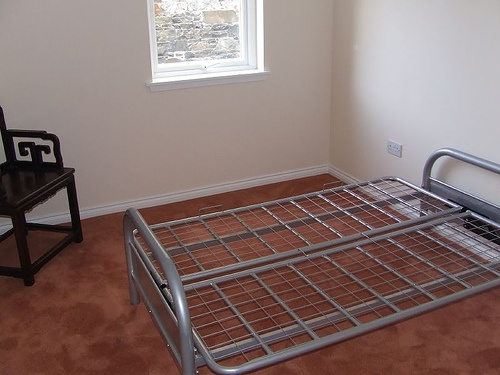Describe the objects in this image and their specific colors. I can see bed in darkgray, maroon, gray, and brown tones and chair in darkgray, black, gray, and maroon tones in this image. 